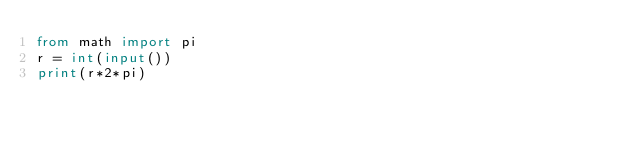<code> <loc_0><loc_0><loc_500><loc_500><_Python_>from math import pi
r = int(input())
print(r*2*pi)
</code> 